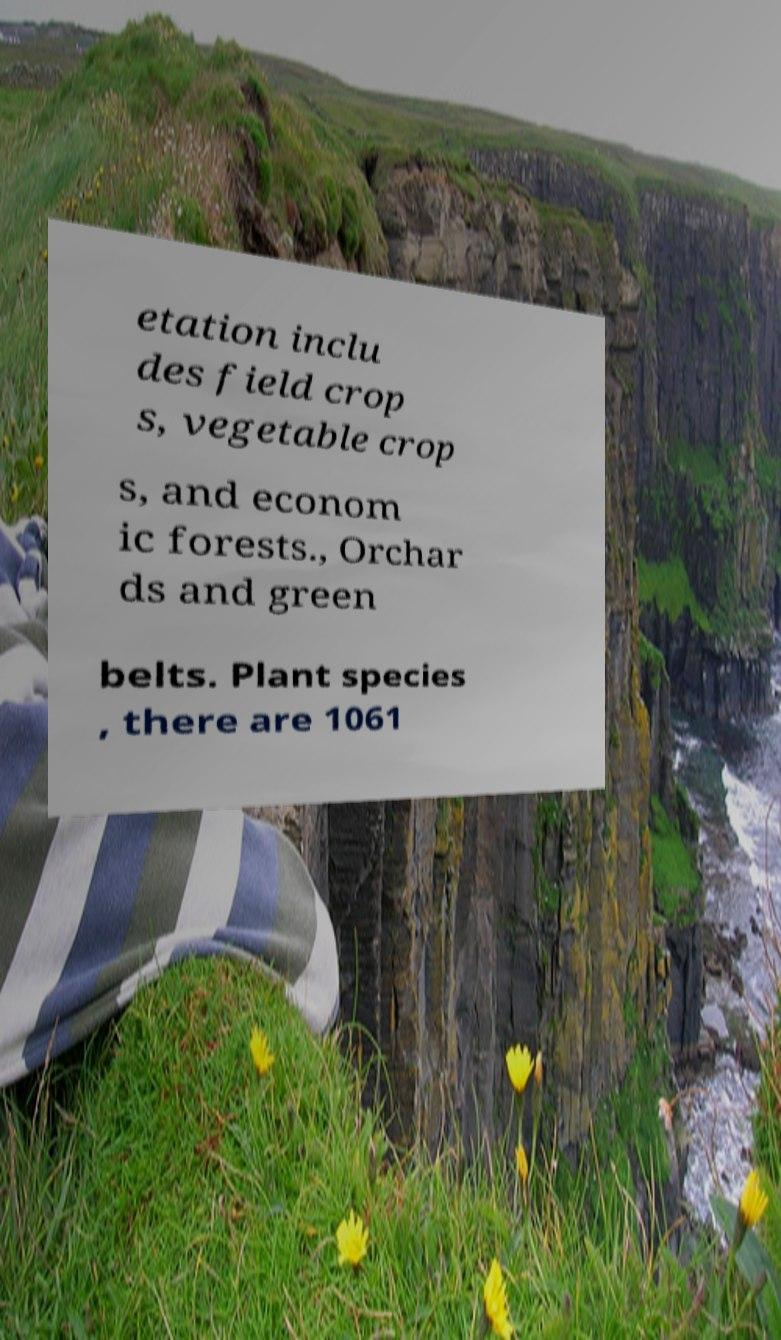Can you read and provide the text displayed in the image?This photo seems to have some interesting text. Can you extract and type it out for me? etation inclu des field crop s, vegetable crop s, and econom ic forests., Orchar ds and green belts. Plant species , there are 1061 